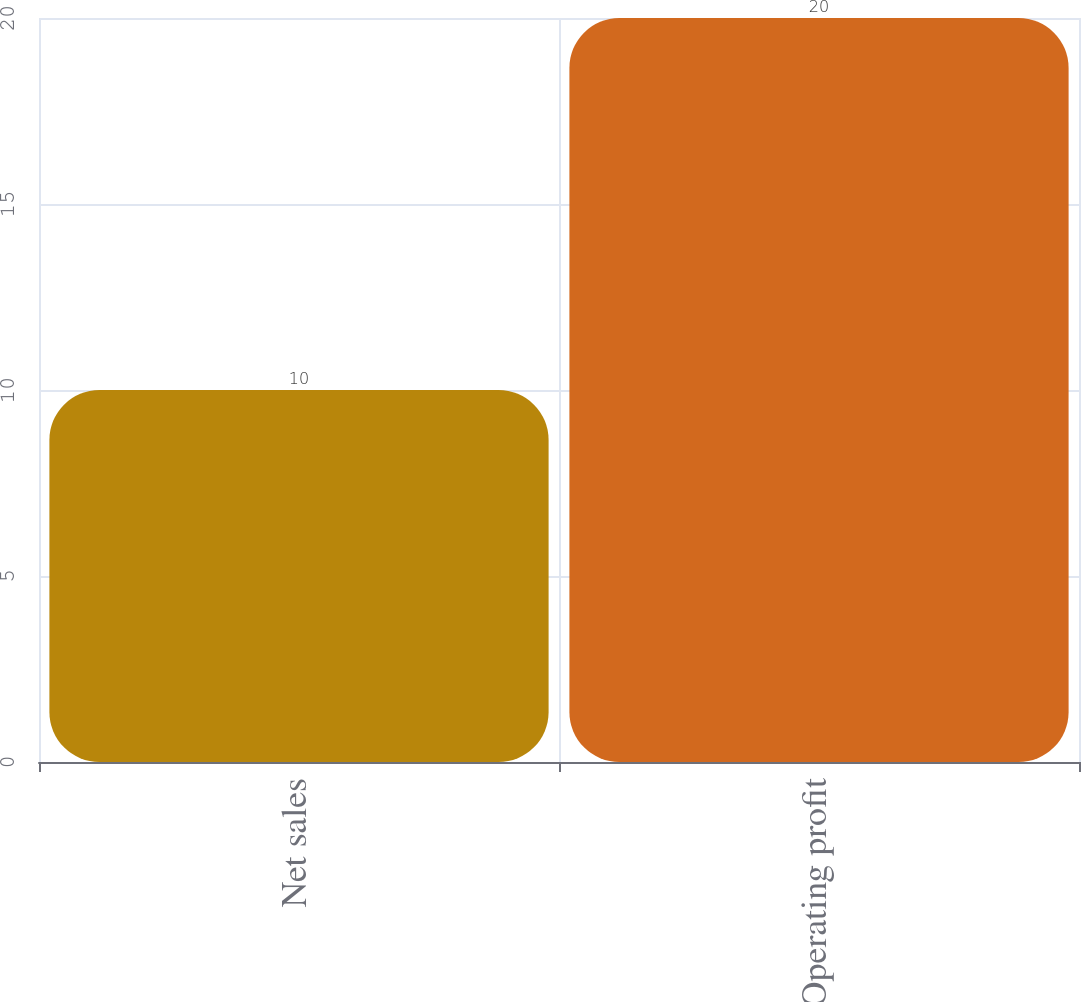Convert chart to OTSL. <chart><loc_0><loc_0><loc_500><loc_500><bar_chart><fcel>Net sales<fcel>Operating profit<nl><fcel>10<fcel>20<nl></chart> 